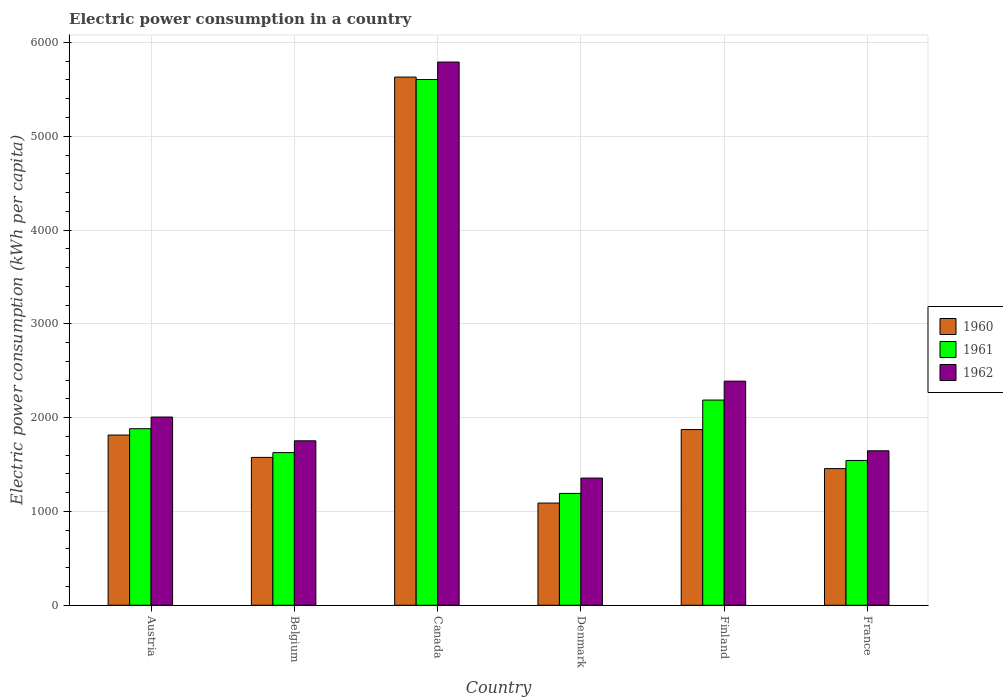How many different coloured bars are there?
Your answer should be very brief. 3. How many groups of bars are there?
Give a very brief answer. 6. Are the number of bars on each tick of the X-axis equal?
Make the answer very short. Yes. How many bars are there on the 1st tick from the left?
Keep it short and to the point. 3. In how many cases, is the number of bars for a given country not equal to the number of legend labels?
Your answer should be compact. 0. What is the electric power consumption in in 1960 in France?
Your response must be concise. 1456.69. Across all countries, what is the maximum electric power consumption in in 1961?
Your answer should be very brief. 5605.11. Across all countries, what is the minimum electric power consumption in in 1962?
Give a very brief answer. 1355.93. In which country was the electric power consumption in in 1960 maximum?
Offer a terse response. Canada. In which country was the electric power consumption in in 1962 minimum?
Provide a succinct answer. Denmark. What is the total electric power consumption in in 1961 in the graph?
Provide a succinct answer. 1.40e+04. What is the difference between the electric power consumption in in 1960 in Austria and that in Canada?
Provide a short and direct response. -3815.95. What is the difference between the electric power consumption in in 1961 in Austria and the electric power consumption in in 1960 in France?
Give a very brief answer. 425.53. What is the average electric power consumption in in 1962 per country?
Your response must be concise. 2490.5. What is the difference between the electric power consumption in of/in 1962 and electric power consumption in of/in 1961 in Denmark?
Your response must be concise. 163.53. What is the ratio of the electric power consumption in in 1960 in Austria to that in Canada?
Provide a succinct answer. 0.32. What is the difference between the highest and the second highest electric power consumption in in 1960?
Give a very brief answer. -3757.34. What is the difference between the highest and the lowest electric power consumption in in 1960?
Give a very brief answer. 4541.02. In how many countries, is the electric power consumption in in 1960 greater than the average electric power consumption in in 1960 taken over all countries?
Provide a succinct answer. 1. What does the 3rd bar from the left in France represents?
Make the answer very short. 1962. What does the 1st bar from the right in Finland represents?
Your answer should be compact. 1962. How many bars are there?
Keep it short and to the point. 18. Are all the bars in the graph horizontal?
Your response must be concise. No. What is the difference between two consecutive major ticks on the Y-axis?
Give a very brief answer. 1000. Are the values on the major ticks of Y-axis written in scientific E-notation?
Your answer should be very brief. No. Does the graph contain grids?
Offer a terse response. Yes. Where does the legend appear in the graph?
Keep it short and to the point. Center right. What is the title of the graph?
Offer a terse response. Electric power consumption in a country. Does "1974" appear as one of the legend labels in the graph?
Make the answer very short. No. What is the label or title of the X-axis?
Ensure brevity in your answer.  Country. What is the label or title of the Y-axis?
Offer a terse response. Electric power consumption (kWh per capita). What is the Electric power consumption (kWh per capita) of 1960 in Austria?
Provide a short and direct response. 1814.68. What is the Electric power consumption (kWh per capita) of 1961 in Austria?
Your answer should be compact. 1882.22. What is the Electric power consumption (kWh per capita) in 1962 in Austria?
Give a very brief answer. 2006.77. What is the Electric power consumption (kWh per capita) in 1960 in Belgium?
Provide a short and direct response. 1576.34. What is the Electric power consumption (kWh per capita) in 1961 in Belgium?
Provide a short and direct response. 1627.51. What is the Electric power consumption (kWh per capita) in 1962 in Belgium?
Offer a terse response. 1753.14. What is the Electric power consumption (kWh per capita) in 1960 in Canada?
Ensure brevity in your answer.  5630.63. What is the Electric power consumption (kWh per capita) in 1961 in Canada?
Offer a terse response. 5605.11. What is the Electric power consumption (kWh per capita) of 1962 in Canada?
Give a very brief answer. 5791.12. What is the Electric power consumption (kWh per capita) in 1960 in Denmark?
Keep it short and to the point. 1089.61. What is the Electric power consumption (kWh per capita) in 1961 in Denmark?
Your answer should be compact. 1192.41. What is the Electric power consumption (kWh per capita) in 1962 in Denmark?
Provide a short and direct response. 1355.93. What is the Electric power consumption (kWh per capita) of 1960 in Finland?
Make the answer very short. 1873.29. What is the Electric power consumption (kWh per capita) of 1961 in Finland?
Your response must be concise. 2187.62. What is the Electric power consumption (kWh per capita) in 1962 in Finland?
Your response must be concise. 2389.21. What is the Electric power consumption (kWh per capita) in 1960 in France?
Give a very brief answer. 1456.69. What is the Electric power consumption (kWh per capita) of 1961 in France?
Give a very brief answer. 1543.71. What is the Electric power consumption (kWh per capita) in 1962 in France?
Give a very brief answer. 1646.83. Across all countries, what is the maximum Electric power consumption (kWh per capita) in 1960?
Provide a succinct answer. 5630.63. Across all countries, what is the maximum Electric power consumption (kWh per capita) in 1961?
Make the answer very short. 5605.11. Across all countries, what is the maximum Electric power consumption (kWh per capita) of 1962?
Ensure brevity in your answer.  5791.12. Across all countries, what is the minimum Electric power consumption (kWh per capita) in 1960?
Ensure brevity in your answer.  1089.61. Across all countries, what is the minimum Electric power consumption (kWh per capita) of 1961?
Your answer should be compact. 1192.41. Across all countries, what is the minimum Electric power consumption (kWh per capita) of 1962?
Your answer should be very brief. 1355.93. What is the total Electric power consumption (kWh per capita) in 1960 in the graph?
Make the answer very short. 1.34e+04. What is the total Electric power consumption (kWh per capita) in 1961 in the graph?
Offer a terse response. 1.40e+04. What is the total Electric power consumption (kWh per capita) in 1962 in the graph?
Offer a very short reply. 1.49e+04. What is the difference between the Electric power consumption (kWh per capita) in 1960 in Austria and that in Belgium?
Give a very brief answer. 238.34. What is the difference between the Electric power consumption (kWh per capita) of 1961 in Austria and that in Belgium?
Give a very brief answer. 254.71. What is the difference between the Electric power consumption (kWh per capita) in 1962 in Austria and that in Belgium?
Provide a short and direct response. 253.63. What is the difference between the Electric power consumption (kWh per capita) of 1960 in Austria and that in Canada?
Provide a short and direct response. -3815.95. What is the difference between the Electric power consumption (kWh per capita) in 1961 in Austria and that in Canada?
Your answer should be compact. -3722.89. What is the difference between the Electric power consumption (kWh per capita) of 1962 in Austria and that in Canada?
Make the answer very short. -3784.35. What is the difference between the Electric power consumption (kWh per capita) of 1960 in Austria and that in Denmark?
Your answer should be compact. 725.06. What is the difference between the Electric power consumption (kWh per capita) in 1961 in Austria and that in Denmark?
Provide a short and direct response. 689.82. What is the difference between the Electric power consumption (kWh per capita) of 1962 in Austria and that in Denmark?
Your answer should be compact. 650.84. What is the difference between the Electric power consumption (kWh per capita) of 1960 in Austria and that in Finland?
Provide a short and direct response. -58.62. What is the difference between the Electric power consumption (kWh per capita) of 1961 in Austria and that in Finland?
Offer a terse response. -305.4. What is the difference between the Electric power consumption (kWh per capita) in 1962 in Austria and that in Finland?
Keep it short and to the point. -382.44. What is the difference between the Electric power consumption (kWh per capita) in 1960 in Austria and that in France?
Your answer should be very brief. 357.98. What is the difference between the Electric power consumption (kWh per capita) in 1961 in Austria and that in France?
Make the answer very short. 338.51. What is the difference between the Electric power consumption (kWh per capita) in 1962 in Austria and that in France?
Your answer should be compact. 359.94. What is the difference between the Electric power consumption (kWh per capita) in 1960 in Belgium and that in Canada?
Your answer should be very brief. -4054.29. What is the difference between the Electric power consumption (kWh per capita) of 1961 in Belgium and that in Canada?
Your answer should be very brief. -3977.6. What is the difference between the Electric power consumption (kWh per capita) in 1962 in Belgium and that in Canada?
Provide a succinct answer. -4037.98. What is the difference between the Electric power consumption (kWh per capita) in 1960 in Belgium and that in Denmark?
Your answer should be compact. 486.72. What is the difference between the Electric power consumption (kWh per capita) in 1961 in Belgium and that in Denmark?
Your response must be concise. 435.11. What is the difference between the Electric power consumption (kWh per capita) in 1962 in Belgium and that in Denmark?
Make the answer very short. 397.21. What is the difference between the Electric power consumption (kWh per capita) of 1960 in Belgium and that in Finland?
Offer a terse response. -296.95. What is the difference between the Electric power consumption (kWh per capita) in 1961 in Belgium and that in Finland?
Make the answer very short. -560.11. What is the difference between the Electric power consumption (kWh per capita) in 1962 in Belgium and that in Finland?
Your response must be concise. -636.07. What is the difference between the Electric power consumption (kWh per capita) in 1960 in Belgium and that in France?
Your response must be concise. 119.65. What is the difference between the Electric power consumption (kWh per capita) in 1961 in Belgium and that in France?
Keep it short and to the point. 83.8. What is the difference between the Electric power consumption (kWh per capita) in 1962 in Belgium and that in France?
Provide a short and direct response. 106.31. What is the difference between the Electric power consumption (kWh per capita) of 1960 in Canada and that in Denmark?
Offer a terse response. 4541.02. What is the difference between the Electric power consumption (kWh per capita) of 1961 in Canada and that in Denmark?
Give a very brief answer. 4412.71. What is the difference between the Electric power consumption (kWh per capita) in 1962 in Canada and that in Denmark?
Offer a terse response. 4435.19. What is the difference between the Electric power consumption (kWh per capita) in 1960 in Canada and that in Finland?
Provide a succinct answer. 3757.34. What is the difference between the Electric power consumption (kWh per capita) in 1961 in Canada and that in Finland?
Keep it short and to the point. 3417.49. What is the difference between the Electric power consumption (kWh per capita) of 1962 in Canada and that in Finland?
Make the answer very short. 3401.92. What is the difference between the Electric power consumption (kWh per capita) in 1960 in Canada and that in France?
Your answer should be compact. 4173.94. What is the difference between the Electric power consumption (kWh per capita) in 1961 in Canada and that in France?
Keep it short and to the point. 4061.4. What is the difference between the Electric power consumption (kWh per capita) of 1962 in Canada and that in France?
Offer a very short reply. 4144.29. What is the difference between the Electric power consumption (kWh per capita) in 1960 in Denmark and that in Finland?
Provide a short and direct response. -783.68. What is the difference between the Electric power consumption (kWh per capita) of 1961 in Denmark and that in Finland?
Keep it short and to the point. -995.22. What is the difference between the Electric power consumption (kWh per capita) of 1962 in Denmark and that in Finland?
Your answer should be compact. -1033.28. What is the difference between the Electric power consumption (kWh per capita) in 1960 in Denmark and that in France?
Your answer should be very brief. -367.08. What is the difference between the Electric power consumption (kWh per capita) of 1961 in Denmark and that in France?
Give a very brief answer. -351.31. What is the difference between the Electric power consumption (kWh per capita) of 1962 in Denmark and that in France?
Offer a terse response. -290.9. What is the difference between the Electric power consumption (kWh per capita) of 1960 in Finland and that in France?
Give a very brief answer. 416.6. What is the difference between the Electric power consumption (kWh per capita) of 1961 in Finland and that in France?
Provide a short and direct response. 643.91. What is the difference between the Electric power consumption (kWh per capita) of 1962 in Finland and that in France?
Make the answer very short. 742.38. What is the difference between the Electric power consumption (kWh per capita) in 1960 in Austria and the Electric power consumption (kWh per capita) in 1961 in Belgium?
Your response must be concise. 187.16. What is the difference between the Electric power consumption (kWh per capita) in 1960 in Austria and the Electric power consumption (kWh per capita) in 1962 in Belgium?
Ensure brevity in your answer.  61.53. What is the difference between the Electric power consumption (kWh per capita) of 1961 in Austria and the Electric power consumption (kWh per capita) of 1962 in Belgium?
Your answer should be compact. 129.08. What is the difference between the Electric power consumption (kWh per capita) in 1960 in Austria and the Electric power consumption (kWh per capita) in 1961 in Canada?
Keep it short and to the point. -3790.44. What is the difference between the Electric power consumption (kWh per capita) in 1960 in Austria and the Electric power consumption (kWh per capita) in 1962 in Canada?
Make the answer very short. -3976.45. What is the difference between the Electric power consumption (kWh per capita) in 1961 in Austria and the Electric power consumption (kWh per capita) in 1962 in Canada?
Provide a short and direct response. -3908.9. What is the difference between the Electric power consumption (kWh per capita) in 1960 in Austria and the Electric power consumption (kWh per capita) in 1961 in Denmark?
Make the answer very short. 622.27. What is the difference between the Electric power consumption (kWh per capita) in 1960 in Austria and the Electric power consumption (kWh per capita) in 1962 in Denmark?
Provide a succinct answer. 458.74. What is the difference between the Electric power consumption (kWh per capita) in 1961 in Austria and the Electric power consumption (kWh per capita) in 1962 in Denmark?
Provide a succinct answer. 526.29. What is the difference between the Electric power consumption (kWh per capita) in 1960 in Austria and the Electric power consumption (kWh per capita) in 1961 in Finland?
Make the answer very short. -372.95. What is the difference between the Electric power consumption (kWh per capita) in 1960 in Austria and the Electric power consumption (kWh per capita) in 1962 in Finland?
Offer a very short reply. -574.53. What is the difference between the Electric power consumption (kWh per capita) of 1961 in Austria and the Electric power consumption (kWh per capita) of 1962 in Finland?
Your response must be concise. -506.99. What is the difference between the Electric power consumption (kWh per capita) in 1960 in Austria and the Electric power consumption (kWh per capita) in 1961 in France?
Ensure brevity in your answer.  270.96. What is the difference between the Electric power consumption (kWh per capita) of 1960 in Austria and the Electric power consumption (kWh per capita) of 1962 in France?
Ensure brevity in your answer.  167.84. What is the difference between the Electric power consumption (kWh per capita) of 1961 in Austria and the Electric power consumption (kWh per capita) of 1962 in France?
Provide a short and direct response. 235.39. What is the difference between the Electric power consumption (kWh per capita) in 1960 in Belgium and the Electric power consumption (kWh per capita) in 1961 in Canada?
Your answer should be compact. -4028.77. What is the difference between the Electric power consumption (kWh per capita) of 1960 in Belgium and the Electric power consumption (kWh per capita) of 1962 in Canada?
Give a very brief answer. -4214.79. What is the difference between the Electric power consumption (kWh per capita) of 1961 in Belgium and the Electric power consumption (kWh per capita) of 1962 in Canada?
Your answer should be compact. -4163.61. What is the difference between the Electric power consumption (kWh per capita) of 1960 in Belgium and the Electric power consumption (kWh per capita) of 1961 in Denmark?
Provide a short and direct response. 383.93. What is the difference between the Electric power consumption (kWh per capita) in 1960 in Belgium and the Electric power consumption (kWh per capita) in 1962 in Denmark?
Your answer should be compact. 220.41. What is the difference between the Electric power consumption (kWh per capita) in 1961 in Belgium and the Electric power consumption (kWh per capita) in 1962 in Denmark?
Offer a terse response. 271.58. What is the difference between the Electric power consumption (kWh per capita) of 1960 in Belgium and the Electric power consumption (kWh per capita) of 1961 in Finland?
Ensure brevity in your answer.  -611.28. What is the difference between the Electric power consumption (kWh per capita) in 1960 in Belgium and the Electric power consumption (kWh per capita) in 1962 in Finland?
Your response must be concise. -812.87. What is the difference between the Electric power consumption (kWh per capita) in 1961 in Belgium and the Electric power consumption (kWh per capita) in 1962 in Finland?
Offer a terse response. -761.7. What is the difference between the Electric power consumption (kWh per capita) in 1960 in Belgium and the Electric power consumption (kWh per capita) in 1961 in France?
Your response must be concise. 32.63. What is the difference between the Electric power consumption (kWh per capita) in 1960 in Belgium and the Electric power consumption (kWh per capita) in 1962 in France?
Provide a short and direct response. -70.49. What is the difference between the Electric power consumption (kWh per capita) of 1961 in Belgium and the Electric power consumption (kWh per capita) of 1962 in France?
Keep it short and to the point. -19.32. What is the difference between the Electric power consumption (kWh per capita) in 1960 in Canada and the Electric power consumption (kWh per capita) in 1961 in Denmark?
Offer a terse response. 4438.22. What is the difference between the Electric power consumption (kWh per capita) in 1960 in Canada and the Electric power consumption (kWh per capita) in 1962 in Denmark?
Provide a short and direct response. 4274.7. What is the difference between the Electric power consumption (kWh per capita) of 1961 in Canada and the Electric power consumption (kWh per capita) of 1962 in Denmark?
Your answer should be very brief. 4249.18. What is the difference between the Electric power consumption (kWh per capita) in 1960 in Canada and the Electric power consumption (kWh per capita) in 1961 in Finland?
Ensure brevity in your answer.  3443.01. What is the difference between the Electric power consumption (kWh per capita) of 1960 in Canada and the Electric power consumption (kWh per capita) of 1962 in Finland?
Keep it short and to the point. 3241.42. What is the difference between the Electric power consumption (kWh per capita) in 1961 in Canada and the Electric power consumption (kWh per capita) in 1962 in Finland?
Make the answer very short. 3215.9. What is the difference between the Electric power consumption (kWh per capita) of 1960 in Canada and the Electric power consumption (kWh per capita) of 1961 in France?
Make the answer very short. 4086.92. What is the difference between the Electric power consumption (kWh per capita) of 1960 in Canada and the Electric power consumption (kWh per capita) of 1962 in France?
Provide a succinct answer. 3983.8. What is the difference between the Electric power consumption (kWh per capita) of 1961 in Canada and the Electric power consumption (kWh per capita) of 1962 in France?
Provide a short and direct response. 3958.28. What is the difference between the Electric power consumption (kWh per capita) of 1960 in Denmark and the Electric power consumption (kWh per capita) of 1961 in Finland?
Ensure brevity in your answer.  -1098.01. What is the difference between the Electric power consumption (kWh per capita) of 1960 in Denmark and the Electric power consumption (kWh per capita) of 1962 in Finland?
Your answer should be very brief. -1299.6. What is the difference between the Electric power consumption (kWh per capita) of 1961 in Denmark and the Electric power consumption (kWh per capita) of 1962 in Finland?
Give a very brief answer. -1196.8. What is the difference between the Electric power consumption (kWh per capita) of 1960 in Denmark and the Electric power consumption (kWh per capita) of 1961 in France?
Your answer should be very brief. -454.1. What is the difference between the Electric power consumption (kWh per capita) in 1960 in Denmark and the Electric power consumption (kWh per capita) in 1962 in France?
Give a very brief answer. -557.22. What is the difference between the Electric power consumption (kWh per capita) in 1961 in Denmark and the Electric power consumption (kWh per capita) in 1962 in France?
Offer a terse response. -454.43. What is the difference between the Electric power consumption (kWh per capita) in 1960 in Finland and the Electric power consumption (kWh per capita) in 1961 in France?
Offer a terse response. 329.58. What is the difference between the Electric power consumption (kWh per capita) in 1960 in Finland and the Electric power consumption (kWh per capita) in 1962 in France?
Provide a succinct answer. 226.46. What is the difference between the Electric power consumption (kWh per capita) in 1961 in Finland and the Electric power consumption (kWh per capita) in 1962 in France?
Make the answer very short. 540.79. What is the average Electric power consumption (kWh per capita) of 1960 per country?
Provide a succinct answer. 2240.21. What is the average Electric power consumption (kWh per capita) in 1961 per country?
Your answer should be compact. 2339.76. What is the average Electric power consumption (kWh per capita) in 1962 per country?
Make the answer very short. 2490.5. What is the difference between the Electric power consumption (kWh per capita) of 1960 and Electric power consumption (kWh per capita) of 1961 in Austria?
Provide a succinct answer. -67.55. What is the difference between the Electric power consumption (kWh per capita) in 1960 and Electric power consumption (kWh per capita) in 1962 in Austria?
Your answer should be very brief. -192.09. What is the difference between the Electric power consumption (kWh per capita) in 1961 and Electric power consumption (kWh per capita) in 1962 in Austria?
Offer a very short reply. -124.55. What is the difference between the Electric power consumption (kWh per capita) of 1960 and Electric power consumption (kWh per capita) of 1961 in Belgium?
Provide a succinct answer. -51.17. What is the difference between the Electric power consumption (kWh per capita) in 1960 and Electric power consumption (kWh per capita) in 1962 in Belgium?
Your answer should be compact. -176.81. What is the difference between the Electric power consumption (kWh per capita) in 1961 and Electric power consumption (kWh per capita) in 1962 in Belgium?
Your response must be concise. -125.63. What is the difference between the Electric power consumption (kWh per capita) of 1960 and Electric power consumption (kWh per capita) of 1961 in Canada?
Your answer should be very brief. 25.52. What is the difference between the Electric power consumption (kWh per capita) of 1960 and Electric power consumption (kWh per capita) of 1962 in Canada?
Give a very brief answer. -160.5. What is the difference between the Electric power consumption (kWh per capita) in 1961 and Electric power consumption (kWh per capita) in 1962 in Canada?
Your response must be concise. -186.01. What is the difference between the Electric power consumption (kWh per capita) of 1960 and Electric power consumption (kWh per capita) of 1961 in Denmark?
Ensure brevity in your answer.  -102.79. What is the difference between the Electric power consumption (kWh per capita) in 1960 and Electric power consumption (kWh per capita) in 1962 in Denmark?
Keep it short and to the point. -266.32. What is the difference between the Electric power consumption (kWh per capita) in 1961 and Electric power consumption (kWh per capita) in 1962 in Denmark?
Your response must be concise. -163.53. What is the difference between the Electric power consumption (kWh per capita) of 1960 and Electric power consumption (kWh per capita) of 1961 in Finland?
Ensure brevity in your answer.  -314.33. What is the difference between the Electric power consumption (kWh per capita) in 1960 and Electric power consumption (kWh per capita) in 1962 in Finland?
Your response must be concise. -515.92. What is the difference between the Electric power consumption (kWh per capita) of 1961 and Electric power consumption (kWh per capita) of 1962 in Finland?
Keep it short and to the point. -201.59. What is the difference between the Electric power consumption (kWh per capita) in 1960 and Electric power consumption (kWh per capita) in 1961 in France?
Provide a short and direct response. -87.02. What is the difference between the Electric power consumption (kWh per capita) in 1960 and Electric power consumption (kWh per capita) in 1962 in France?
Offer a very short reply. -190.14. What is the difference between the Electric power consumption (kWh per capita) in 1961 and Electric power consumption (kWh per capita) in 1962 in France?
Make the answer very short. -103.12. What is the ratio of the Electric power consumption (kWh per capita) of 1960 in Austria to that in Belgium?
Offer a very short reply. 1.15. What is the ratio of the Electric power consumption (kWh per capita) of 1961 in Austria to that in Belgium?
Give a very brief answer. 1.16. What is the ratio of the Electric power consumption (kWh per capita) of 1962 in Austria to that in Belgium?
Offer a terse response. 1.14. What is the ratio of the Electric power consumption (kWh per capita) of 1960 in Austria to that in Canada?
Make the answer very short. 0.32. What is the ratio of the Electric power consumption (kWh per capita) of 1961 in Austria to that in Canada?
Make the answer very short. 0.34. What is the ratio of the Electric power consumption (kWh per capita) in 1962 in Austria to that in Canada?
Your answer should be very brief. 0.35. What is the ratio of the Electric power consumption (kWh per capita) in 1960 in Austria to that in Denmark?
Keep it short and to the point. 1.67. What is the ratio of the Electric power consumption (kWh per capita) of 1961 in Austria to that in Denmark?
Ensure brevity in your answer.  1.58. What is the ratio of the Electric power consumption (kWh per capita) of 1962 in Austria to that in Denmark?
Keep it short and to the point. 1.48. What is the ratio of the Electric power consumption (kWh per capita) of 1960 in Austria to that in Finland?
Ensure brevity in your answer.  0.97. What is the ratio of the Electric power consumption (kWh per capita) in 1961 in Austria to that in Finland?
Offer a very short reply. 0.86. What is the ratio of the Electric power consumption (kWh per capita) in 1962 in Austria to that in Finland?
Offer a very short reply. 0.84. What is the ratio of the Electric power consumption (kWh per capita) of 1960 in Austria to that in France?
Your response must be concise. 1.25. What is the ratio of the Electric power consumption (kWh per capita) of 1961 in Austria to that in France?
Provide a succinct answer. 1.22. What is the ratio of the Electric power consumption (kWh per capita) in 1962 in Austria to that in France?
Your answer should be compact. 1.22. What is the ratio of the Electric power consumption (kWh per capita) in 1960 in Belgium to that in Canada?
Provide a succinct answer. 0.28. What is the ratio of the Electric power consumption (kWh per capita) of 1961 in Belgium to that in Canada?
Your answer should be very brief. 0.29. What is the ratio of the Electric power consumption (kWh per capita) in 1962 in Belgium to that in Canada?
Your answer should be compact. 0.3. What is the ratio of the Electric power consumption (kWh per capita) in 1960 in Belgium to that in Denmark?
Provide a short and direct response. 1.45. What is the ratio of the Electric power consumption (kWh per capita) in 1961 in Belgium to that in Denmark?
Offer a terse response. 1.36. What is the ratio of the Electric power consumption (kWh per capita) of 1962 in Belgium to that in Denmark?
Offer a terse response. 1.29. What is the ratio of the Electric power consumption (kWh per capita) of 1960 in Belgium to that in Finland?
Your answer should be very brief. 0.84. What is the ratio of the Electric power consumption (kWh per capita) in 1961 in Belgium to that in Finland?
Your response must be concise. 0.74. What is the ratio of the Electric power consumption (kWh per capita) of 1962 in Belgium to that in Finland?
Ensure brevity in your answer.  0.73. What is the ratio of the Electric power consumption (kWh per capita) in 1960 in Belgium to that in France?
Give a very brief answer. 1.08. What is the ratio of the Electric power consumption (kWh per capita) in 1961 in Belgium to that in France?
Ensure brevity in your answer.  1.05. What is the ratio of the Electric power consumption (kWh per capita) of 1962 in Belgium to that in France?
Ensure brevity in your answer.  1.06. What is the ratio of the Electric power consumption (kWh per capita) of 1960 in Canada to that in Denmark?
Give a very brief answer. 5.17. What is the ratio of the Electric power consumption (kWh per capita) of 1961 in Canada to that in Denmark?
Offer a very short reply. 4.7. What is the ratio of the Electric power consumption (kWh per capita) of 1962 in Canada to that in Denmark?
Keep it short and to the point. 4.27. What is the ratio of the Electric power consumption (kWh per capita) of 1960 in Canada to that in Finland?
Offer a very short reply. 3.01. What is the ratio of the Electric power consumption (kWh per capita) in 1961 in Canada to that in Finland?
Provide a short and direct response. 2.56. What is the ratio of the Electric power consumption (kWh per capita) of 1962 in Canada to that in Finland?
Provide a short and direct response. 2.42. What is the ratio of the Electric power consumption (kWh per capita) of 1960 in Canada to that in France?
Keep it short and to the point. 3.87. What is the ratio of the Electric power consumption (kWh per capita) of 1961 in Canada to that in France?
Make the answer very short. 3.63. What is the ratio of the Electric power consumption (kWh per capita) in 1962 in Canada to that in France?
Your answer should be compact. 3.52. What is the ratio of the Electric power consumption (kWh per capita) of 1960 in Denmark to that in Finland?
Keep it short and to the point. 0.58. What is the ratio of the Electric power consumption (kWh per capita) of 1961 in Denmark to that in Finland?
Ensure brevity in your answer.  0.55. What is the ratio of the Electric power consumption (kWh per capita) of 1962 in Denmark to that in Finland?
Ensure brevity in your answer.  0.57. What is the ratio of the Electric power consumption (kWh per capita) in 1960 in Denmark to that in France?
Your answer should be very brief. 0.75. What is the ratio of the Electric power consumption (kWh per capita) of 1961 in Denmark to that in France?
Offer a very short reply. 0.77. What is the ratio of the Electric power consumption (kWh per capita) in 1962 in Denmark to that in France?
Ensure brevity in your answer.  0.82. What is the ratio of the Electric power consumption (kWh per capita) of 1960 in Finland to that in France?
Make the answer very short. 1.29. What is the ratio of the Electric power consumption (kWh per capita) of 1961 in Finland to that in France?
Your response must be concise. 1.42. What is the ratio of the Electric power consumption (kWh per capita) of 1962 in Finland to that in France?
Your response must be concise. 1.45. What is the difference between the highest and the second highest Electric power consumption (kWh per capita) in 1960?
Provide a short and direct response. 3757.34. What is the difference between the highest and the second highest Electric power consumption (kWh per capita) in 1961?
Give a very brief answer. 3417.49. What is the difference between the highest and the second highest Electric power consumption (kWh per capita) in 1962?
Give a very brief answer. 3401.92. What is the difference between the highest and the lowest Electric power consumption (kWh per capita) of 1960?
Offer a terse response. 4541.02. What is the difference between the highest and the lowest Electric power consumption (kWh per capita) in 1961?
Keep it short and to the point. 4412.71. What is the difference between the highest and the lowest Electric power consumption (kWh per capita) of 1962?
Make the answer very short. 4435.19. 